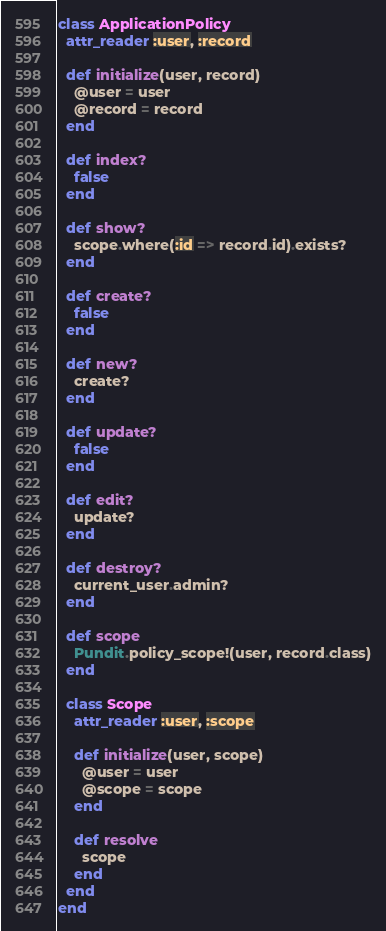Convert code to text. <code><loc_0><loc_0><loc_500><loc_500><_Ruby_>class ApplicationPolicy
  attr_reader :user, :record

  def initialize(user, record)
    @user = user
    @record = record
  end

  def index?
    false
  end

  def show?
    scope.where(:id => record.id).exists?
  end

  def create?
    false
  end

  def new?
    create?
  end

  def update?
    false
  end

  def edit?
    update?
  end

  def destroy?
    current_user.admin?
  end

  def scope
    Pundit.policy_scope!(user, record.class)
  end

  class Scope
    attr_reader :user, :scope

    def initialize(user, scope)
      @user = user
      @scope = scope
    end

    def resolve
      scope
    end
  end
end

</code> 